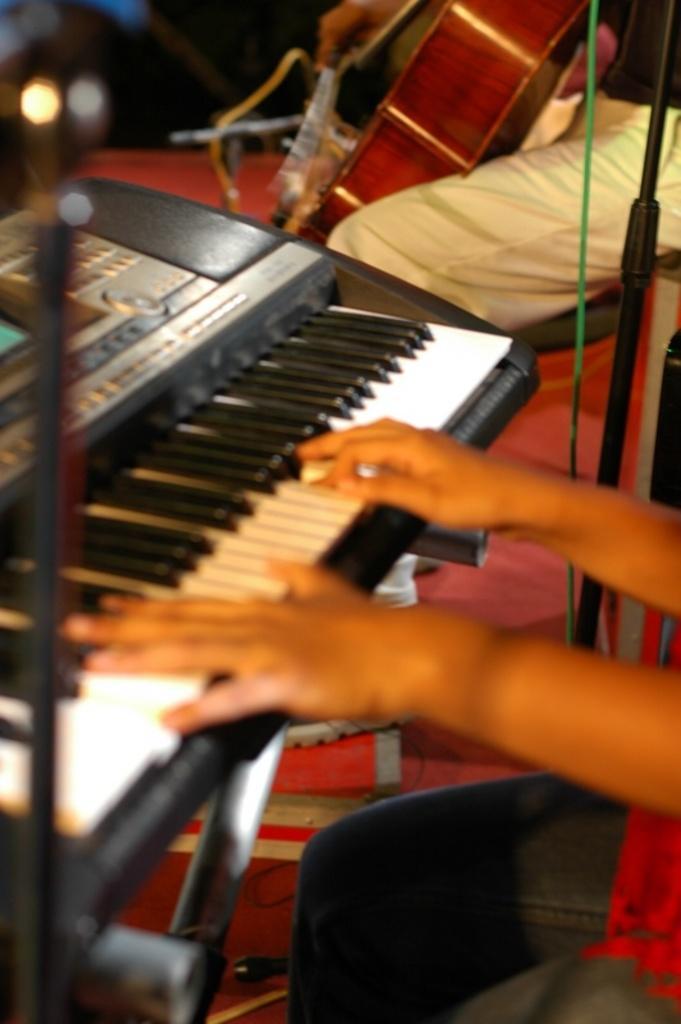Can you describe this image briefly? In this image i can see a human hand playing piano, at the right side i can see a person holding guitar. 